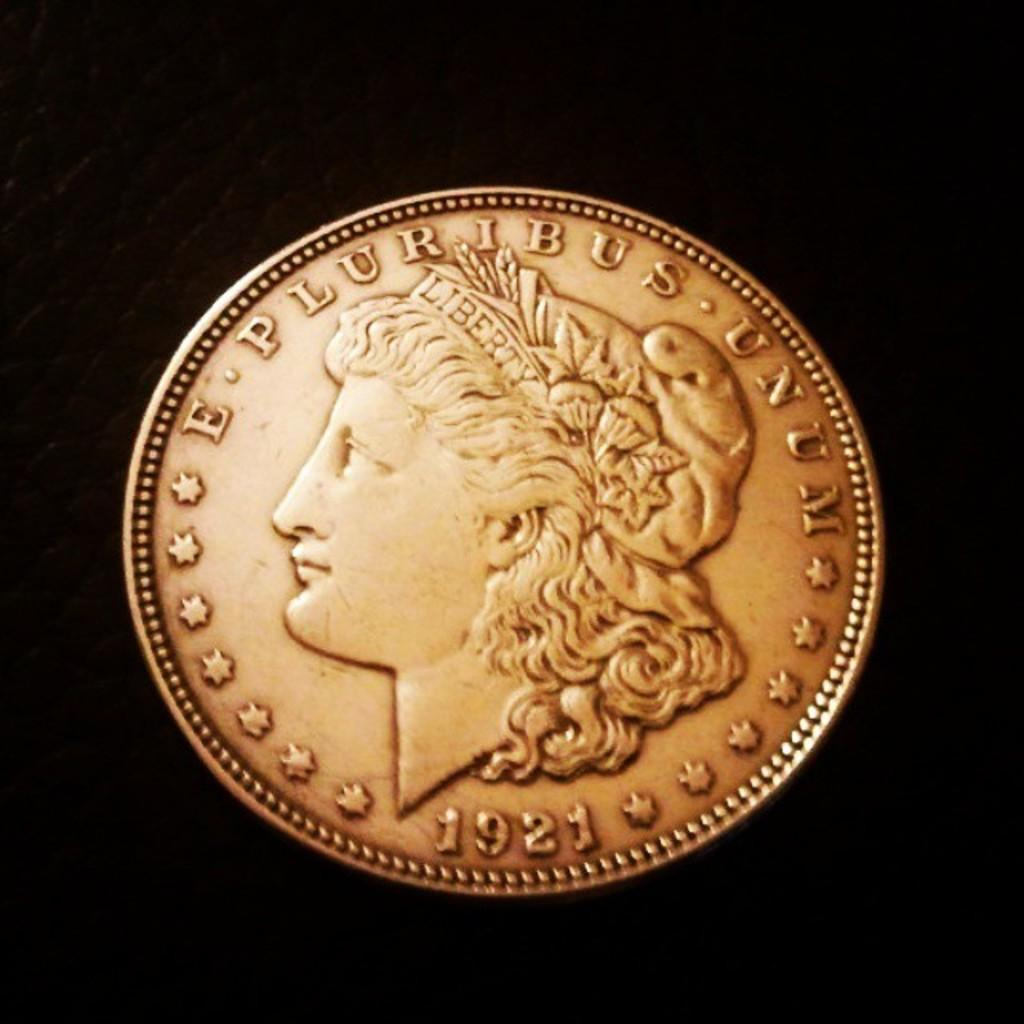<image>
Present a compact description of the photo's key features. A coin from 1921 bears the phrase "E pluribus unum." 